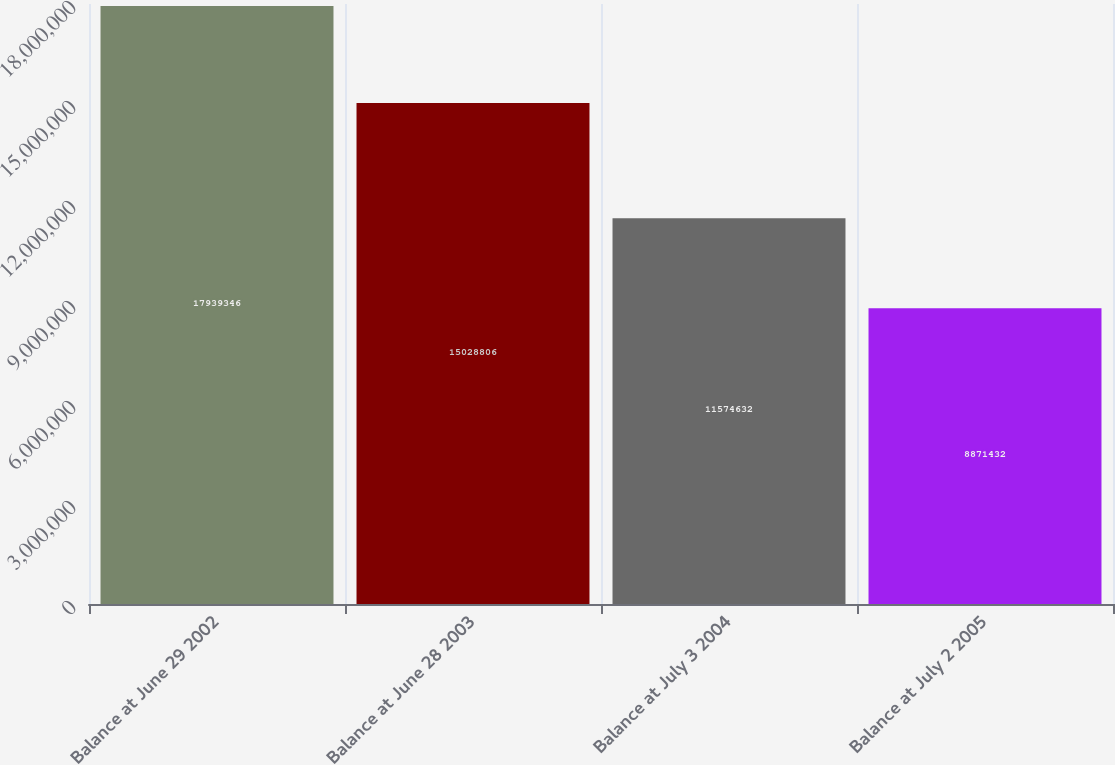Convert chart to OTSL. <chart><loc_0><loc_0><loc_500><loc_500><bar_chart><fcel>Balance at June 29 2002<fcel>Balance at June 28 2003<fcel>Balance at July 3 2004<fcel>Balance at July 2 2005<nl><fcel>1.79393e+07<fcel>1.50288e+07<fcel>1.15746e+07<fcel>8.87143e+06<nl></chart> 